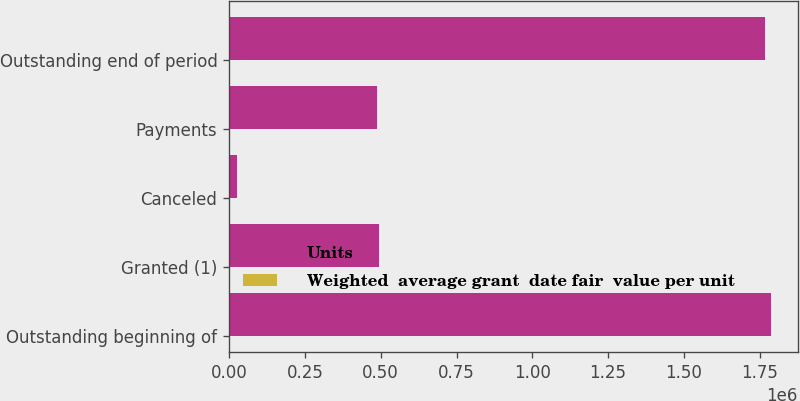Convert chart to OTSL. <chart><loc_0><loc_0><loc_500><loc_500><stacked_bar_chart><ecel><fcel>Outstanding beginning of<fcel>Granted (1)<fcel>Canceled<fcel>Payments<fcel>Outstanding end of period<nl><fcel>Units<fcel>1.78673e+06<fcel>495099<fcel>25160<fcel>488304<fcel>1.76836e+06<nl><fcel>Weighted  average grant  date fair  value per unit<fcel>40.94<fcel>83.24<fcel>44.07<fcel>44.07<fcel>51.88<nl></chart> 